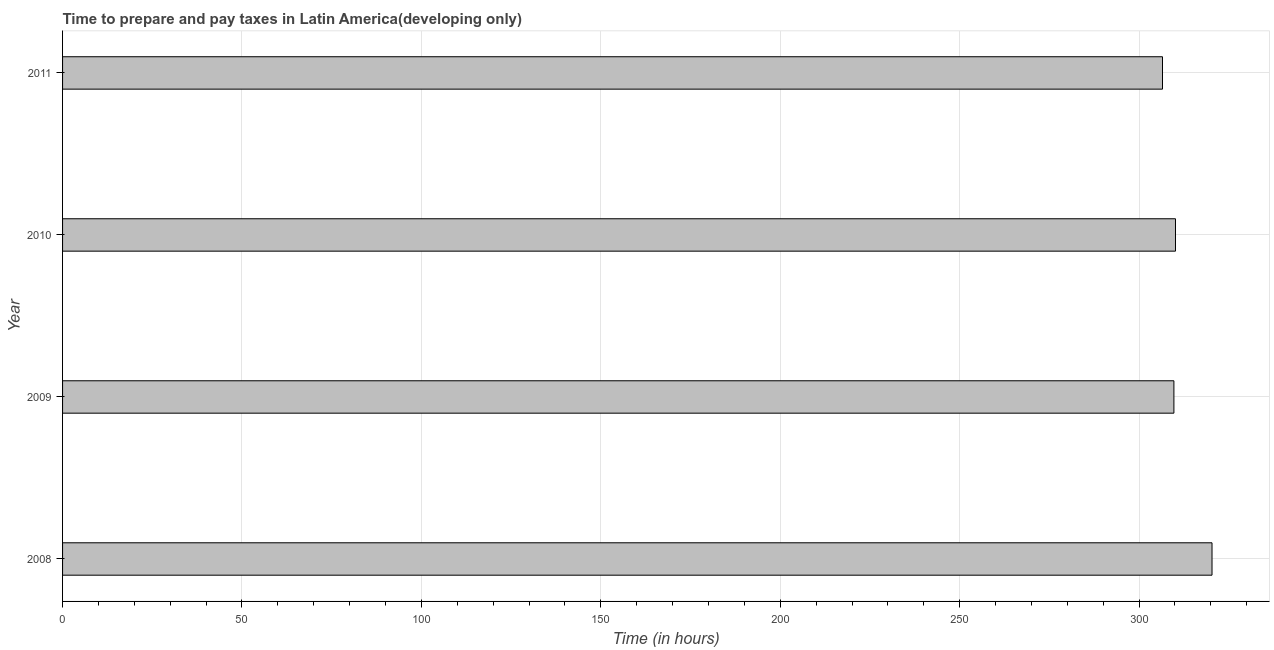Does the graph contain grids?
Provide a succinct answer. Yes. What is the title of the graph?
Your response must be concise. Time to prepare and pay taxes in Latin America(developing only). What is the label or title of the X-axis?
Offer a terse response. Time (in hours). What is the label or title of the Y-axis?
Keep it short and to the point. Year. What is the time to prepare and pay taxes in 2011?
Your response must be concise. 306.52. Across all years, what is the maximum time to prepare and pay taxes?
Your answer should be very brief. 320.32. Across all years, what is the minimum time to prepare and pay taxes?
Keep it short and to the point. 306.52. What is the sum of the time to prepare and pay taxes?
Provide a succinct answer. 1246.7. What is the difference between the time to prepare and pay taxes in 2010 and 2011?
Your answer should be compact. 3.62. What is the average time to prepare and pay taxes per year?
Ensure brevity in your answer.  311.67. What is the median time to prepare and pay taxes?
Provide a short and direct response. 309.92. In how many years, is the time to prepare and pay taxes greater than 290 hours?
Give a very brief answer. 4. Do a majority of the years between 2008 and 2011 (inclusive) have time to prepare and pay taxes greater than 180 hours?
Make the answer very short. Yes. What is the ratio of the time to prepare and pay taxes in 2009 to that in 2011?
Your answer should be very brief. 1.01. What is the difference between the highest and the second highest time to prepare and pay taxes?
Your response must be concise. 10.18. Is the sum of the time to prepare and pay taxes in 2008 and 2011 greater than the maximum time to prepare and pay taxes across all years?
Provide a short and direct response. Yes. In how many years, is the time to prepare and pay taxes greater than the average time to prepare and pay taxes taken over all years?
Your answer should be compact. 1. How many bars are there?
Offer a terse response. 4. How many years are there in the graph?
Your answer should be very brief. 4. What is the difference between two consecutive major ticks on the X-axis?
Make the answer very short. 50. Are the values on the major ticks of X-axis written in scientific E-notation?
Give a very brief answer. No. What is the Time (in hours) of 2008?
Your answer should be very brief. 320.32. What is the Time (in hours) of 2009?
Make the answer very short. 309.7. What is the Time (in hours) in 2010?
Provide a succinct answer. 310.14. What is the Time (in hours) of 2011?
Keep it short and to the point. 306.52. What is the difference between the Time (in hours) in 2008 and 2009?
Your answer should be very brief. 10.62. What is the difference between the Time (in hours) in 2008 and 2010?
Give a very brief answer. 10.18. What is the difference between the Time (in hours) in 2008 and 2011?
Your response must be concise. 13.8. What is the difference between the Time (in hours) in 2009 and 2010?
Offer a very short reply. -0.44. What is the difference between the Time (in hours) in 2009 and 2011?
Your response must be concise. 3.18. What is the difference between the Time (in hours) in 2010 and 2011?
Give a very brief answer. 3.62. What is the ratio of the Time (in hours) in 2008 to that in 2009?
Give a very brief answer. 1.03. What is the ratio of the Time (in hours) in 2008 to that in 2010?
Offer a terse response. 1.03. What is the ratio of the Time (in hours) in 2008 to that in 2011?
Your response must be concise. 1.04. What is the ratio of the Time (in hours) in 2009 to that in 2010?
Your answer should be compact. 1. What is the ratio of the Time (in hours) in 2009 to that in 2011?
Provide a succinct answer. 1.01. 